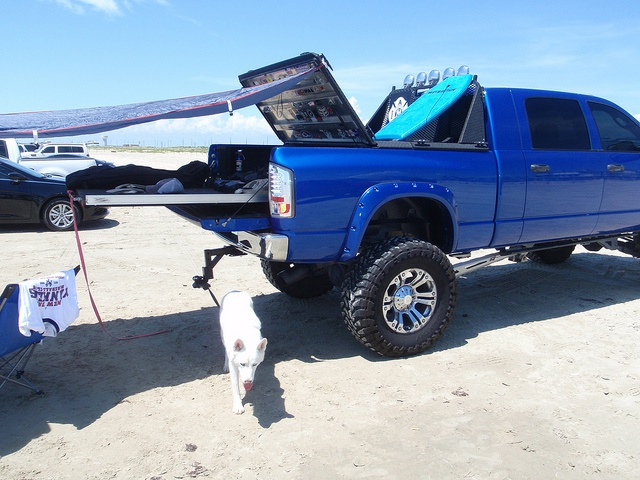Describe the objects in this image and their specific colors. I can see truck in lightblue, black, darkblue, navy, and blue tones, car in lightblue, black, navy, and gray tones, dog in lightblue, white, darkgray, and gray tones, car in lightblue, white, gray, and darkgray tones, and car in lightblue, white, darkblue, navy, and gray tones in this image. 